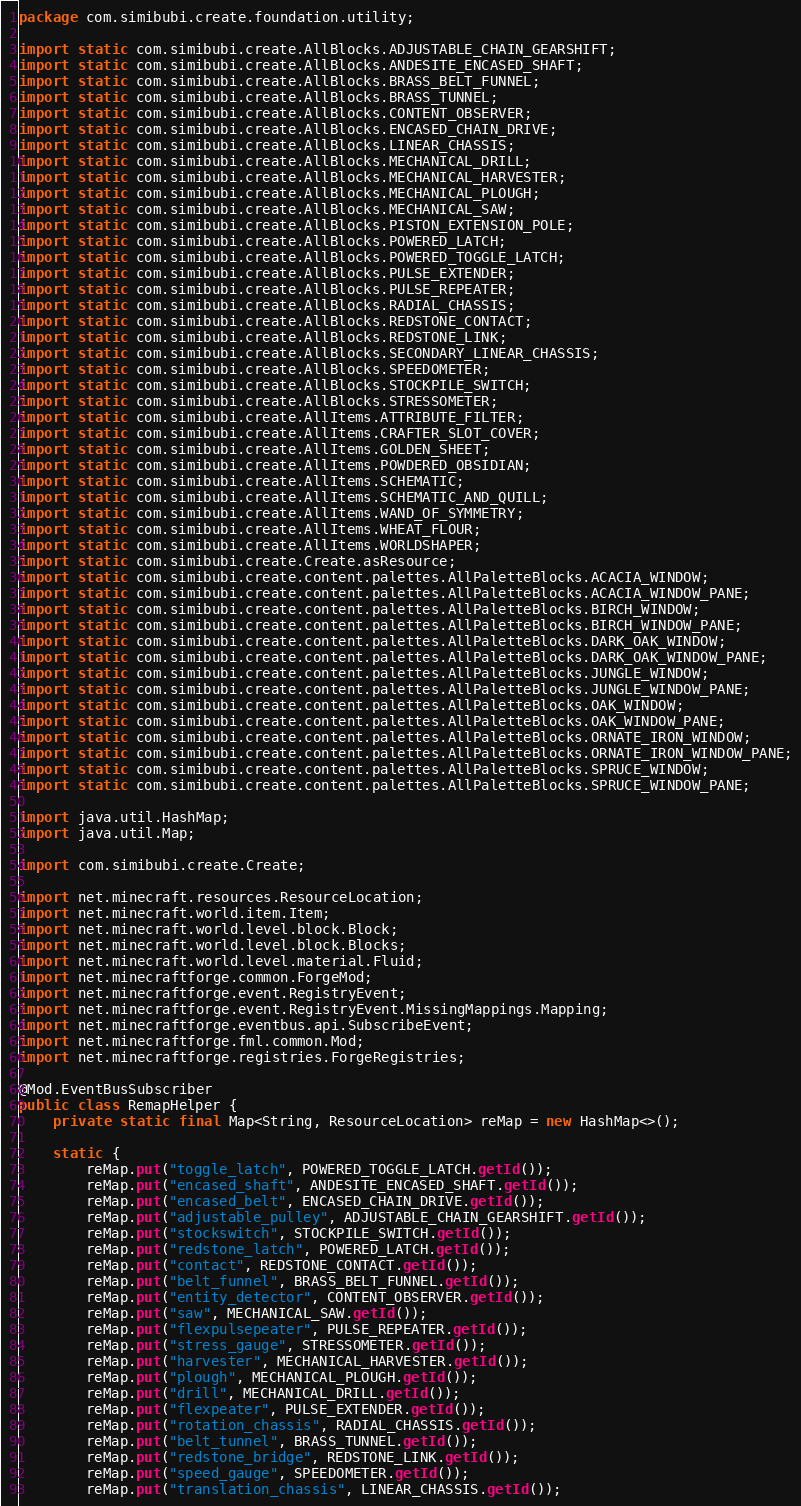Convert code to text. <code><loc_0><loc_0><loc_500><loc_500><_Java_>package com.simibubi.create.foundation.utility;

import static com.simibubi.create.AllBlocks.ADJUSTABLE_CHAIN_GEARSHIFT;
import static com.simibubi.create.AllBlocks.ANDESITE_ENCASED_SHAFT;
import static com.simibubi.create.AllBlocks.BRASS_BELT_FUNNEL;
import static com.simibubi.create.AllBlocks.BRASS_TUNNEL;
import static com.simibubi.create.AllBlocks.CONTENT_OBSERVER;
import static com.simibubi.create.AllBlocks.ENCASED_CHAIN_DRIVE;
import static com.simibubi.create.AllBlocks.LINEAR_CHASSIS;
import static com.simibubi.create.AllBlocks.MECHANICAL_DRILL;
import static com.simibubi.create.AllBlocks.MECHANICAL_HARVESTER;
import static com.simibubi.create.AllBlocks.MECHANICAL_PLOUGH;
import static com.simibubi.create.AllBlocks.MECHANICAL_SAW;
import static com.simibubi.create.AllBlocks.PISTON_EXTENSION_POLE;
import static com.simibubi.create.AllBlocks.POWERED_LATCH;
import static com.simibubi.create.AllBlocks.POWERED_TOGGLE_LATCH;
import static com.simibubi.create.AllBlocks.PULSE_EXTENDER;
import static com.simibubi.create.AllBlocks.PULSE_REPEATER;
import static com.simibubi.create.AllBlocks.RADIAL_CHASSIS;
import static com.simibubi.create.AllBlocks.REDSTONE_CONTACT;
import static com.simibubi.create.AllBlocks.REDSTONE_LINK;
import static com.simibubi.create.AllBlocks.SECONDARY_LINEAR_CHASSIS;
import static com.simibubi.create.AllBlocks.SPEEDOMETER;
import static com.simibubi.create.AllBlocks.STOCKPILE_SWITCH;
import static com.simibubi.create.AllBlocks.STRESSOMETER;
import static com.simibubi.create.AllItems.ATTRIBUTE_FILTER;
import static com.simibubi.create.AllItems.CRAFTER_SLOT_COVER;
import static com.simibubi.create.AllItems.GOLDEN_SHEET;
import static com.simibubi.create.AllItems.POWDERED_OBSIDIAN;
import static com.simibubi.create.AllItems.SCHEMATIC;
import static com.simibubi.create.AllItems.SCHEMATIC_AND_QUILL;
import static com.simibubi.create.AllItems.WAND_OF_SYMMETRY;
import static com.simibubi.create.AllItems.WHEAT_FLOUR;
import static com.simibubi.create.AllItems.WORLDSHAPER;
import static com.simibubi.create.Create.asResource;
import static com.simibubi.create.content.palettes.AllPaletteBlocks.ACACIA_WINDOW;
import static com.simibubi.create.content.palettes.AllPaletteBlocks.ACACIA_WINDOW_PANE;
import static com.simibubi.create.content.palettes.AllPaletteBlocks.BIRCH_WINDOW;
import static com.simibubi.create.content.palettes.AllPaletteBlocks.BIRCH_WINDOW_PANE;
import static com.simibubi.create.content.palettes.AllPaletteBlocks.DARK_OAK_WINDOW;
import static com.simibubi.create.content.palettes.AllPaletteBlocks.DARK_OAK_WINDOW_PANE;
import static com.simibubi.create.content.palettes.AllPaletteBlocks.JUNGLE_WINDOW;
import static com.simibubi.create.content.palettes.AllPaletteBlocks.JUNGLE_WINDOW_PANE;
import static com.simibubi.create.content.palettes.AllPaletteBlocks.OAK_WINDOW;
import static com.simibubi.create.content.palettes.AllPaletteBlocks.OAK_WINDOW_PANE;
import static com.simibubi.create.content.palettes.AllPaletteBlocks.ORNATE_IRON_WINDOW;
import static com.simibubi.create.content.palettes.AllPaletteBlocks.ORNATE_IRON_WINDOW_PANE;
import static com.simibubi.create.content.palettes.AllPaletteBlocks.SPRUCE_WINDOW;
import static com.simibubi.create.content.palettes.AllPaletteBlocks.SPRUCE_WINDOW_PANE;

import java.util.HashMap;
import java.util.Map;

import com.simibubi.create.Create;

import net.minecraft.resources.ResourceLocation;
import net.minecraft.world.item.Item;
import net.minecraft.world.level.block.Block;
import net.minecraft.world.level.block.Blocks;
import net.minecraft.world.level.material.Fluid;
import net.minecraftforge.common.ForgeMod;
import net.minecraftforge.event.RegistryEvent;
import net.minecraftforge.event.RegistryEvent.MissingMappings.Mapping;
import net.minecraftforge.eventbus.api.SubscribeEvent;
import net.minecraftforge.fml.common.Mod;
import net.minecraftforge.registries.ForgeRegistries;

@Mod.EventBusSubscriber
public class RemapHelper {
	private static final Map<String, ResourceLocation> reMap = new HashMap<>();

	static {
		reMap.put("toggle_latch", POWERED_TOGGLE_LATCH.getId());
		reMap.put("encased_shaft", ANDESITE_ENCASED_SHAFT.getId());
		reMap.put("encased_belt", ENCASED_CHAIN_DRIVE.getId());
		reMap.put("adjustable_pulley", ADJUSTABLE_CHAIN_GEARSHIFT.getId());
		reMap.put("stockswitch", STOCKPILE_SWITCH.getId());
		reMap.put("redstone_latch", POWERED_LATCH.getId());
		reMap.put("contact", REDSTONE_CONTACT.getId());
		reMap.put("belt_funnel", BRASS_BELT_FUNNEL.getId());
		reMap.put("entity_detector", CONTENT_OBSERVER.getId());
		reMap.put("saw", MECHANICAL_SAW.getId());
		reMap.put("flexpulsepeater", PULSE_REPEATER.getId());
		reMap.put("stress_gauge", STRESSOMETER.getId());
		reMap.put("harvester", MECHANICAL_HARVESTER.getId());
		reMap.put("plough", MECHANICAL_PLOUGH.getId());
		reMap.put("drill", MECHANICAL_DRILL.getId());
		reMap.put("flexpeater", PULSE_EXTENDER.getId());
		reMap.put("rotation_chassis", RADIAL_CHASSIS.getId());
		reMap.put("belt_tunnel", BRASS_TUNNEL.getId());
		reMap.put("redstone_bridge", REDSTONE_LINK.getId());
		reMap.put("speed_gauge", SPEEDOMETER.getId());
		reMap.put("translation_chassis", LINEAR_CHASSIS.getId());</code> 